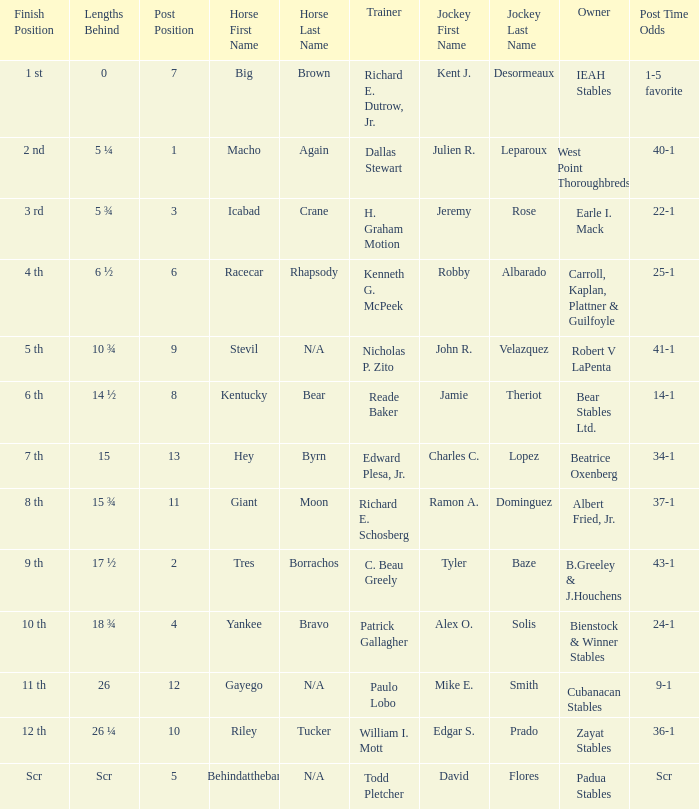What is the lengths behind of Jeremy Rose? 5 ¾. 